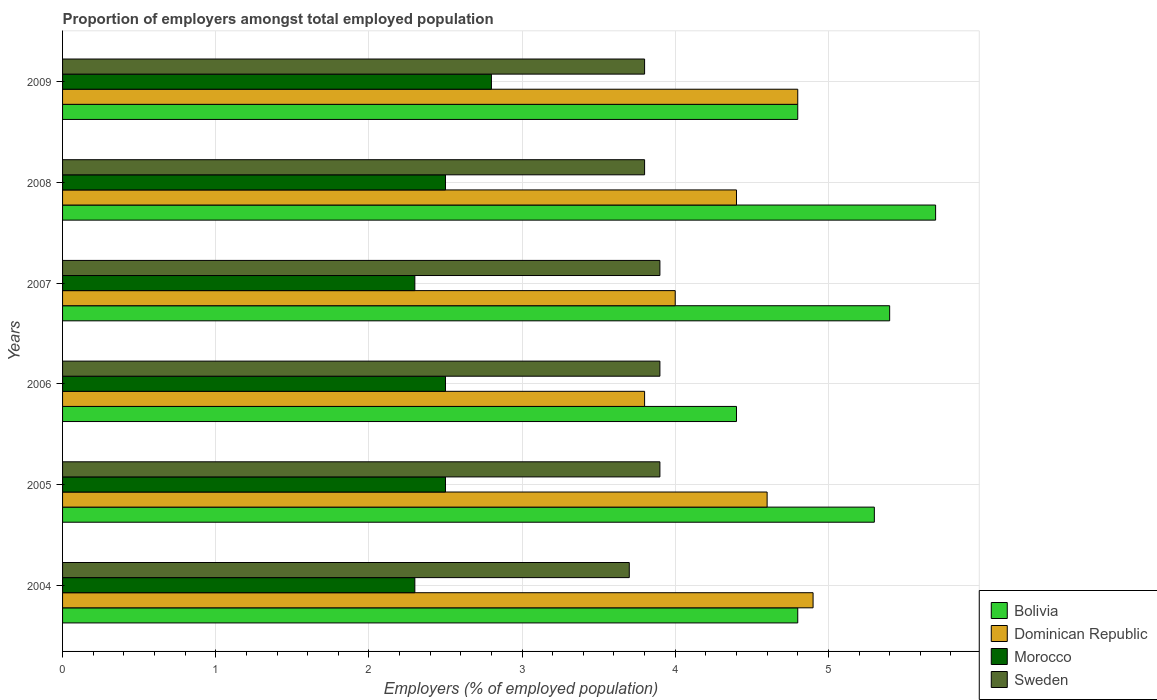How many bars are there on the 1st tick from the top?
Give a very brief answer. 4. How many bars are there on the 5th tick from the bottom?
Keep it short and to the point. 4. In how many cases, is the number of bars for a given year not equal to the number of legend labels?
Make the answer very short. 0. What is the proportion of employers in Dominican Republic in 2005?
Give a very brief answer. 4.6. Across all years, what is the maximum proportion of employers in Sweden?
Give a very brief answer. 3.9. Across all years, what is the minimum proportion of employers in Bolivia?
Your answer should be compact. 4.4. In which year was the proportion of employers in Morocco maximum?
Your answer should be compact. 2009. In which year was the proportion of employers in Bolivia minimum?
Ensure brevity in your answer.  2006. What is the total proportion of employers in Morocco in the graph?
Give a very brief answer. 14.9. What is the difference between the proportion of employers in Sweden in 2005 and that in 2008?
Provide a succinct answer. 0.1. What is the difference between the proportion of employers in Morocco in 2005 and the proportion of employers in Sweden in 2008?
Keep it short and to the point. -1.3. What is the average proportion of employers in Morocco per year?
Your response must be concise. 2.48. In the year 2008, what is the difference between the proportion of employers in Sweden and proportion of employers in Dominican Republic?
Provide a short and direct response. -0.6. In how many years, is the proportion of employers in Dominican Republic greater than 5.4 %?
Keep it short and to the point. 0. What is the ratio of the proportion of employers in Bolivia in 2006 to that in 2009?
Your answer should be compact. 0.92. Is the proportion of employers in Bolivia in 2007 less than that in 2009?
Offer a terse response. No. What is the difference between the highest and the lowest proportion of employers in Bolivia?
Your answer should be compact. 1.3. What does the 3rd bar from the top in 2009 represents?
Offer a very short reply. Dominican Republic. What does the 2nd bar from the bottom in 2004 represents?
Offer a very short reply. Dominican Republic. Is it the case that in every year, the sum of the proportion of employers in Morocco and proportion of employers in Sweden is greater than the proportion of employers in Bolivia?
Your answer should be very brief. Yes. Are all the bars in the graph horizontal?
Give a very brief answer. Yes. How many years are there in the graph?
Provide a succinct answer. 6. Are the values on the major ticks of X-axis written in scientific E-notation?
Provide a short and direct response. No. Does the graph contain any zero values?
Offer a terse response. No. Where does the legend appear in the graph?
Your answer should be very brief. Bottom right. How many legend labels are there?
Make the answer very short. 4. What is the title of the graph?
Keep it short and to the point. Proportion of employers amongst total employed population. What is the label or title of the X-axis?
Offer a terse response. Employers (% of employed population). What is the label or title of the Y-axis?
Your answer should be very brief. Years. What is the Employers (% of employed population) in Bolivia in 2004?
Provide a short and direct response. 4.8. What is the Employers (% of employed population) of Dominican Republic in 2004?
Provide a succinct answer. 4.9. What is the Employers (% of employed population) in Morocco in 2004?
Make the answer very short. 2.3. What is the Employers (% of employed population) in Sweden in 2004?
Make the answer very short. 3.7. What is the Employers (% of employed population) in Bolivia in 2005?
Your answer should be very brief. 5.3. What is the Employers (% of employed population) of Dominican Republic in 2005?
Your response must be concise. 4.6. What is the Employers (% of employed population) of Morocco in 2005?
Offer a very short reply. 2.5. What is the Employers (% of employed population) of Sweden in 2005?
Your answer should be compact. 3.9. What is the Employers (% of employed population) in Bolivia in 2006?
Provide a short and direct response. 4.4. What is the Employers (% of employed population) in Dominican Republic in 2006?
Your response must be concise. 3.8. What is the Employers (% of employed population) of Morocco in 2006?
Ensure brevity in your answer.  2.5. What is the Employers (% of employed population) of Sweden in 2006?
Offer a very short reply. 3.9. What is the Employers (% of employed population) in Bolivia in 2007?
Your answer should be compact. 5.4. What is the Employers (% of employed population) in Dominican Republic in 2007?
Ensure brevity in your answer.  4. What is the Employers (% of employed population) of Morocco in 2007?
Ensure brevity in your answer.  2.3. What is the Employers (% of employed population) in Sweden in 2007?
Make the answer very short. 3.9. What is the Employers (% of employed population) of Bolivia in 2008?
Provide a succinct answer. 5.7. What is the Employers (% of employed population) in Dominican Republic in 2008?
Your response must be concise. 4.4. What is the Employers (% of employed population) of Sweden in 2008?
Your response must be concise. 3.8. What is the Employers (% of employed population) in Bolivia in 2009?
Provide a succinct answer. 4.8. What is the Employers (% of employed population) in Dominican Republic in 2009?
Make the answer very short. 4.8. What is the Employers (% of employed population) of Morocco in 2009?
Make the answer very short. 2.8. What is the Employers (% of employed population) in Sweden in 2009?
Provide a succinct answer. 3.8. Across all years, what is the maximum Employers (% of employed population) in Bolivia?
Make the answer very short. 5.7. Across all years, what is the maximum Employers (% of employed population) in Dominican Republic?
Provide a short and direct response. 4.9. Across all years, what is the maximum Employers (% of employed population) in Morocco?
Make the answer very short. 2.8. Across all years, what is the maximum Employers (% of employed population) of Sweden?
Keep it short and to the point. 3.9. Across all years, what is the minimum Employers (% of employed population) in Bolivia?
Provide a short and direct response. 4.4. Across all years, what is the minimum Employers (% of employed population) of Dominican Republic?
Ensure brevity in your answer.  3.8. Across all years, what is the minimum Employers (% of employed population) of Morocco?
Your answer should be very brief. 2.3. Across all years, what is the minimum Employers (% of employed population) in Sweden?
Keep it short and to the point. 3.7. What is the total Employers (% of employed population) in Bolivia in the graph?
Keep it short and to the point. 30.4. What is the total Employers (% of employed population) of Dominican Republic in the graph?
Give a very brief answer. 26.5. What is the difference between the Employers (% of employed population) of Bolivia in 2004 and that in 2005?
Give a very brief answer. -0.5. What is the difference between the Employers (% of employed population) of Dominican Republic in 2004 and that in 2006?
Give a very brief answer. 1.1. What is the difference between the Employers (% of employed population) in Morocco in 2004 and that in 2007?
Provide a short and direct response. 0. What is the difference between the Employers (% of employed population) in Sweden in 2004 and that in 2007?
Provide a short and direct response. -0.2. What is the difference between the Employers (% of employed population) of Bolivia in 2004 and that in 2008?
Keep it short and to the point. -0.9. What is the difference between the Employers (% of employed population) of Morocco in 2004 and that in 2008?
Provide a succinct answer. -0.2. What is the difference between the Employers (% of employed population) of Sweden in 2004 and that in 2008?
Offer a very short reply. -0.1. What is the difference between the Employers (% of employed population) in Bolivia in 2004 and that in 2009?
Give a very brief answer. 0. What is the difference between the Employers (% of employed population) of Morocco in 2004 and that in 2009?
Make the answer very short. -0.5. What is the difference between the Employers (% of employed population) in Sweden in 2004 and that in 2009?
Ensure brevity in your answer.  -0.1. What is the difference between the Employers (% of employed population) in Morocco in 2005 and that in 2006?
Make the answer very short. 0. What is the difference between the Employers (% of employed population) of Sweden in 2005 and that in 2006?
Your response must be concise. 0. What is the difference between the Employers (% of employed population) of Bolivia in 2005 and that in 2007?
Offer a terse response. -0.1. What is the difference between the Employers (% of employed population) in Dominican Republic in 2005 and that in 2007?
Make the answer very short. 0.6. What is the difference between the Employers (% of employed population) of Morocco in 2005 and that in 2007?
Ensure brevity in your answer.  0.2. What is the difference between the Employers (% of employed population) of Bolivia in 2005 and that in 2008?
Ensure brevity in your answer.  -0.4. What is the difference between the Employers (% of employed population) of Sweden in 2005 and that in 2008?
Ensure brevity in your answer.  0.1. What is the difference between the Employers (% of employed population) of Bolivia in 2005 and that in 2009?
Give a very brief answer. 0.5. What is the difference between the Employers (% of employed population) of Sweden in 2005 and that in 2009?
Make the answer very short. 0.1. What is the difference between the Employers (% of employed population) in Morocco in 2006 and that in 2007?
Your answer should be very brief. 0.2. What is the difference between the Employers (% of employed population) of Dominican Republic in 2006 and that in 2008?
Offer a terse response. -0.6. What is the difference between the Employers (% of employed population) of Morocco in 2006 and that in 2008?
Offer a very short reply. 0. What is the difference between the Employers (% of employed population) in Sweden in 2006 and that in 2008?
Keep it short and to the point. 0.1. What is the difference between the Employers (% of employed population) of Dominican Republic in 2006 and that in 2009?
Ensure brevity in your answer.  -1. What is the difference between the Employers (% of employed population) in Morocco in 2006 and that in 2009?
Your answer should be compact. -0.3. What is the difference between the Employers (% of employed population) of Sweden in 2006 and that in 2009?
Ensure brevity in your answer.  0.1. What is the difference between the Employers (% of employed population) of Bolivia in 2007 and that in 2008?
Keep it short and to the point. -0.3. What is the difference between the Employers (% of employed population) in Dominican Republic in 2007 and that in 2008?
Offer a very short reply. -0.4. What is the difference between the Employers (% of employed population) of Bolivia in 2008 and that in 2009?
Make the answer very short. 0.9. What is the difference between the Employers (% of employed population) of Morocco in 2008 and that in 2009?
Your answer should be very brief. -0.3. What is the difference between the Employers (% of employed population) in Sweden in 2008 and that in 2009?
Offer a terse response. 0. What is the difference between the Employers (% of employed population) of Bolivia in 2004 and the Employers (% of employed population) of Dominican Republic in 2005?
Offer a very short reply. 0.2. What is the difference between the Employers (% of employed population) of Bolivia in 2004 and the Employers (% of employed population) of Sweden in 2005?
Keep it short and to the point. 0.9. What is the difference between the Employers (% of employed population) in Dominican Republic in 2004 and the Employers (% of employed population) in Sweden in 2005?
Keep it short and to the point. 1. What is the difference between the Employers (% of employed population) in Morocco in 2004 and the Employers (% of employed population) in Sweden in 2005?
Provide a succinct answer. -1.6. What is the difference between the Employers (% of employed population) in Bolivia in 2004 and the Employers (% of employed population) in Dominican Republic in 2006?
Your answer should be very brief. 1. What is the difference between the Employers (% of employed population) in Bolivia in 2004 and the Employers (% of employed population) in Morocco in 2006?
Provide a short and direct response. 2.3. What is the difference between the Employers (% of employed population) of Dominican Republic in 2004 and the Employers (% of employed population) of Morocco in 2006?
Offer a terse response. 2.4. What is the difference between the Employers (% of employed population) in Morocco in 2004 and the Employers (% of employed population) in Sweden in 2006?
Keep it short and to the point. -1.6. What is the difference between the Employers (% of employed population) of Dominican Republic in 2004 and the Employers (% of employed population) of Morocco in 2007?
Ensure brevity in your answer.  2.6. What is the difference between the Employers (% of employed population) in Morocco in 2004 and the Employers (% of employed population) in Sweden in 2007?
Give a very brief answer. -1.6. What is the difference between the Employers (% of employed population) of Dominican Republic in 2004 and the Employers (% of employed population) of Morocco in 2008?
Offer a very short reply. 2.4. What is the difference between the Employers (% of employed population) in Dominican Republic in 2004 and the Employers (% of employed population) in Sweden in 2008?
Your answer should be compact. 1.1. What is the difference between the Employers (% of employed population) of Bolivia in 2004 and the Employers (% of employed population) of Morocco in 2009?
Offer a terse response. 2. What is the difference between the Employers (% of employed population) of Bolivia in 2004 and the Employers (% of employed population) of Sweden in 2009?
Provide a short and direct response. 1. What is the difference between the Employers (% of employed population) of Dominican Republic in 2004 and the Employers (% of employed population) of Sweden in 2009?
Your response must be concise. 1.1. What is the difference between the Employers (% of employed population) in Morocco in 2004 and the Employers (% of employed population) in Sweden in 2009?
Provide a short and direct response. -1.5. What is the difference between the Employers (% of employed population) in Dominican Republic in 2005 and the Employers (% of employed population) in Sweden in 2006?
Your answer should be very brief. 0.7. What is the difference between the Employers (% of employed population) of Morocco in 2005 and the Employers (% of employed population) of Sweden in 2006?
Give a very brief answer. -1.4. What is the difference between the Employers (% of employed population) in Dominican Republic in 2005 and the Employers (% of employed population) in Sweden in 2007?
Keep it short and to the point. 0.7. What is the difference between the Employers (% of employed population) in Bolivia in 2005 and the Employers (% of employed population) in Dominican Republic in 2008?
Ensure brevity in your answer.  0.9. What is the difference between the Employers (% of employed population) of Bolivia in 2005 and the Employers (% of employed population) of Sweden in 2008?
Ensure brevity in your answer.  1.5. What is the difference between the Employers (% of employed population) in Dominican Republic in 2005 and the Employers (% of employed population) in Morocco in 2008?
Your answer should be compact. 2.1. What is the difference between the Employers (% of employed population) of Dominican Republic in 2005 and the Employers (% of employed population) of Sweden in 2008?
Offer a very short reply. 0.8. What is the difference between the Employers (% of employed population) of Morocco in 2005 and the Employers (% of employed population) of Sweden in 2008?
Give a very brief answer. -1.3. What is the difference between the Employers (% of employed population) in Bolivia in 2005 and the Employers (% of employed population) in Sweden in 2009?
Offer a terse response. 1.5. What is the difference between the Employers (% of employed population) in Dominican Republic in 2005 and the Employers (% of employed population) in Morocco in 2009?
Provide a succinct answer. 1.8. What is the difference between the Employers (% of employed population) of Dominican Republic in 2005 and the Employers (% of employed population) of Sweden in 2009?
Offer a very short reply. 0.8. What is the difference between the Employers (% of employed population) of Bolivia in 2006 and the Employers (% of employed population) of Dominican Republic in 2007?
Provide a succinct answer. 0.4. What is the difference between the Employers (% of employed population) in Bolivia in 2006 and the Employers (% of employed population) in Morocco in 2007?
Your answer should be compact. 2.1. What is the difference between the Employers (% of employed population) in Dominican Republic in 2006 and the Employers (% of employed population) in Sweden in 2007?
Offer a very short reply. -0.1. What is the difference between the Employers (% of employed population) in Bolivia in 2006 and the Employers (% of employed population) in Dominican Republic in 2008?
Offer a very short reply. 0. What is the difference between the Employers (% of employed population) in Bolivia in 2006 and the Employers (% of employed population) in Sweden in 2008?
Provide a short and direct response. 0.6. What is the difference between the Employers (% of employed population) in Dominican Republic in 2006 and the Employers (% of employed population) in Morocco in 2008?
Give a very brief answer. 1.3. What is the difference between the Employers (% of employed population) in Dominican Republic in 2006 and the Employers (% of employed population) in Sweden in 2008?
Your answer should be very brief. 0. What is the difference between the Employers (% of employed population) of Bolivia in 2006 and the Employers (% of employed population) of Dominican Republic in 2009?
Offer a terse response. -0.4. What is the difference between the Employers (% of employed population) in Bolivia in 2006 and the Employers (% of employed population) in Sweden in 2009?
Your response must be concise. 0.6. What is the difference between the Employers (% of employed population) of Dominican Republic in 2006 and the Employers (% of employed population) of Sweden in 2009?
Make the answer very short. 0. What is the difference between the Employers (% of employed population) in Morocco in 2006 and the Employers (% of employed population) in Sweden in 2009?
Give a very brief answer. -1.3. What is the difference between the Employers (% of employed population) in Bolivia in 2007 and the Employers (% of employed population) in Dominican Republic in 2008?
Make the answer very short. 1. What is the difference between the Employers (% of employed population) of Bolivia in 2007 and the Employers (% of employed population) of Morocco in 2008?
Keep it short and to the point. 2.9. What is the difference between the Employers (% of employed population) of Bolivia in 2007 and the Employers (% of employed population) of Sweden in 2008?
Your answer should be very brief. 1.6. What is the difference between the Employers (% of employed population) in Bolivia in 2007 and the Employers (% of employed population) in Dominican Republic in 2009?
Make the answer very short. 0.6. What is the difference between the Employers (% of employed population) of Dominican Republic in 2007 and the Employers (% of employed population) of Morocco in 2009?
Your answer should be very brief. 1.2. What is the difference between the Employers (% of employed population) of Bolivia in 2008 and the Employers (% of employed population) of Dominican Republic in 2009?
Your response must be concise. 0.9. What is the difference between the Employers (% of employed population) of Bolivia in 2008 and the Employers (% of employed population) of Sweden in 2009?
Ensure brevity in your answer.  1.9. What is the difference between the Employers (% of employed population) of Morocco in 2008 and the Employers (% of employed population) of Sweden in 2009?
Keep it short and to the point. -1.3. What is the average Employers (% of employed population) of Bolivia per year?
Your answer should be very brief. 5.07. What is the average Employers (% of employed population) of Dominican Republic per year?
Offer a very short reply. 4.42. What is the average Employers (% of employed population) in Morocco per year?
Provide a short and direct response. 2.48. What is the average Employers (% of employed population) in Sweden per year?
Your response must be concise. 3.83. In the year 2004, what is the difference between the Employers (% of employed population) in Morocco and Employers (% of employed population) in Sweden?
Give a very brief answer. -1.4. In the year 2005, what is the difference between the Employers (% of employed population) in Dominican Republic and Employers (% of employed population) in Morocco?
Provide a short and direct response. 2.1. In the year 2006, what is the difference between the Employers (% of employed population) in Bolivia and Employers (% of employed population) in Dominican Republic?
Ensure brevity in your answer.  0.6. In the year 2006, what is the difference between the Employers (% of employed population) of Bolivia and Employers (% of employed population) of Morocco?
Provide a succinct answer. 1.9. In the year 2006, what is the difference between the Employers (% of employed population) in Bolivia and Employers (% of employed population) in Sweden?
Give a very brief answer. 0.5. In the year 2006, what is the difference between the Employers (% of employed population) in Dominican Republic and Employers (% of employed population) in Morocco?
Keep it short and to the point. 1.3. In the year 2006, what is the difference between the Employers (% of employed population) in Morocco and Employers (% of employed population) in Sweden?
Provide a succinct answer. -1.4. In the year 2007, what is the difference between the Employers (% of employed population) of Bolivia and Employers (% of employed population) of Dominican Republic?
Provide a succinct answer. 1.4. In the year 2007, what is the difference between the Employers (% of employed population) of Dominican Republic and Employers (% of employed population) of Morocco?
Make the answer very short. 1.7. In the year 2007, what is the difference between the Employers (% of employed population) of Dominican Republic and Employers (% of employed population) of Sweden?
Give a very brief answer. 0.1. In the year 2008, what is the difference between the Employers (% of employed population) in Bolivia and Employers (% of employed population) in Morocco?
Keep it short and to the point. 3.2. In the year 2008, what is the difference between the Employers (% of employed population) of Bolivia and Employers (% of employed population) of Sweden?
Make the answer very short. 1.9. In the year 2008, what is the difference between the Employers (% of employed population) in Dominican Republic and Employers (% of employed population) in Morocco?
Offer a very short reply. 1.9. In the year 2008, what is the difference between the Employers (% of employed population) in Dominican Republic and Employers (% of employed population) in Sweden?
Keep it short and to the point. 0.6. In the year 2009, what is the difference between the Employers (% of employed population) in Bolivia and Employers (% of employed population) in Dominican Republic?
Your response must be concise. 0. In the year 2009, what is the difference between the Employers (% of employed population) of Bolivia and Employers (% of employed population) of Sweden?
Provide a succinct answer. 1. In the year 2009, what is the difference between the Employers (% of employed population) of Dominican Republic and Employers (% of employed population) of Morocco?
Your answer should be compact. 2. In the year 2009, what is the difference between the Employers (% of employed population) in Dominican Republic and Employers (% of employed population) in Sweden?
Ensure brevity in your answer.  1. What is the ratio of the Employers (% of employed population) in Bolivia in 2004 to that in 2005?
Offer a terse response. 0.91. What is the ratio of the Employers (% of employed population) in Dominican Republic in 2004 to that in 2005?
Your answer should be very brief. 1.07. What is the ratio of the Employers (% of employed population) in Morocco in 2004 to that in 2005?
Give a very brief answer. 0.92. What is the ratio of the Employers (% of employed population) in Sweden in 2004 to that in 2005?
Your response must be concise. 0.95. What is the ratio of the Employers (% of employed population) of Dominican Republic in 2004 to that in 2006?
Provide a short and direct response. 1.29. What is the ratio of the Employers (% of employed population) in Sweden in 2004 to that in 2006?
Your response must be concise. 0.95. What is the ratio of the Employers (% of employed population) in Bolivia in 2004 to that in 2007?
Provide a succinct answer. 0.89. What is the ratio of the Employers (% of employed population) of Dominican Republic in 2004 to that in 2007?
Your answer should be very brief. 1.23. What is the ratio of the Employers (% of employed population) in Sweden in 2004 to that in 2007?
Provide a short and direct response. 0.95. What is the ratio of the Employers (% of employed population) in Bolivia in 2004 to that in 2008?
Offer a very short reply. 0.84. What is the ratio of the Employers (% of employed population) in Dominican Republic in 2004 to that in 2008?
Offer a very short reply. 1.11. What is the ratio of the Employers (% of employed population) in Morocco in 2004 to that in 2008?
Make the answer very short. 0.92. What is the ratio of the Employers (% of employed population) in Sweden in 2004 to that in 2008?
Keep it short and to the point. 0.97. What is the ratio of the Employers (% of employed population) of Bolivia in 2004 to that in 2009?
Keep it short and to the point. 1. What is the ratio of the Employers (% of employed population) in Dominican Republic in 2004 to that in 2009?
Offer a very short reply. 1.02. What is the ratio of the Employers (% of employed population) in Morocco in 2004 to that in 2009?
Your answer should be very brief. 0.82. What is the ratio of the Employers (% of employed population) in Sweden in 2004 to that in 2009?
Give a very brief answer. 0.97. What is the ratio of the Employers (% of employed population) of Bolivia in 2005 to that in 2006?
Provide a short and direct response. 1.2. What is the ratio of the Employers (% of employed population) in Dominican Republic in 2005 to that in 2006?
Ensure brevity in your answer.  1.21. What is the ratio of the Employers (% of employed population) of Morocco in 2005 to that in 2006?
Provide a short and direct response. 1. What is the ratio of the Employers (% of employed population) in Sweden in 2005 to that in 2006?
Ensure brevity in your answer.  1. What is the ratio of the Employers (% of employed population) in Bolivia in 2005 to that in 2007?
Provide a short and direct response. 0.98. What is the ratio of the Employers (% of employed population) in Dominican Republic in 2005 to that in 2007?
Offer a terse response. 1.15. What is the ratio of the Employers (% of employed population) of Morocco in 2005 to that in 2007?
Offer a very short reply. 1.09. What is the ratio of the Employers (% of employed population) in Bolivia in 2005 to that in 2008?
Your answer should be compact. 0.93. What is the ratio of the Employers (% of employed population) of Dominican Republic in 2005 to that in 2008?
Your answer should be very brief. 1.05. What is the ratio of the Employers (% of employed population) in Sweden in 2005 to that in 2008?
Provide a succinct answer. 1.03. What is the ratio of the Employers (% of employed population) in Bolivia in 2005 to that in 2009?
Provide a short and direct response. 1.1. What is the ratio of the Employers (% of employed population) in Dominican Republic in 2005 to that in 2009?
Your answer should be very brief. 0.96. What is the ratio of the Employers (% of employed population) in Morocco in 2005 to that in 2009?
Give a very brief answer. 0.89. What is the ratio of the Employers (% of employed population) of Sweden in 2005 to that in 2009?
Your answer should be compact. 1.03. What is the ratio of the Employers (% of employed population) of Bolivia in 2006 to that in 2007?
Offer a terse response. 0.81. What is the ratio of the Employers (% of employed population) of Dominican Republic in 2006 to that in 2007?
Give a very brief answer. 0.95. What is the ratio of the Employers (% of employed population) in Morocco in 2006 to that in 2007?
Make the answer very short. 1.09. What is the ratio of the Employers (% of employed population) in Sweden in 2006 to that in 2007?
Give a very brief answer. 1. What is the ratio of the Employers (% of employed population) in Bolivia in 2006 to that in 2008?
Your answer should be very brief. 0.77. What is the ratio of the Employers (% of employed population) of Dominican Republic in 2006 to that in 2008?
Ensure brevity in your answer.  0.86. What is the ratio of the Employers (% of employed population) of Morocco in 2006 to that in 2008?
Offer a terse response. 1. What is the ratio of the Employers (% of employed population) in Sweden in 2006 to that in 2008?
Your response must be concise. 1.03. What is the ratio of the Employers (% of employed population) in Bolivia in 2006 to that in 2009?
Keep it short and to the point. 0.92. What is the ratio of the Employers (% of employed population) in Dominican Republic in 2006 to that in 2009?
Provide a short and direct response. 0.79. What is the ratio of the Employers (% of employed population) of Morocco in 2006 to that in 2009?
Offer a terse response. 0.89. What is the ratio of the Employers (% of employed population) of Sweden in 2006 to that in 2009?
Ensure brevity in your answer.  1.03. What is the ratio of the Employers (% of employed population) of Dominican Republic in 2007 to that in 2008?
Make the answer very short. 0.91. What is the ratio of the Employers (% of employed population) of Morocco in 2007 to that in 2008?
Offer a terse response. 0.92. What is the ratio of the Employers (% of employed population) of Sweden in 2007 to that in 2008?
Provide a succinct answer. 1.03. What is the ratio of the Employers (% of employed population) of Dominican Republic in 2007 to that in 2009?
Your response must be concise. 0.83. What is the ratio of the Employers (% of employed population) of Morocco in 2007 to that in 2009?
Your answer should be compact. 0.82. What is the ratio of the Employers (% of employed population) in Sweden in 2007 to that in 2009?
Give a very brief answer. 1.03. What is the ratio of the Employers (% of employed population) in Bolivia in 2008 to that in 2009?
Give a very brief answer. 1.19. What is the ratio of the Employers (% of employed population) in Dominican Republic in 2008 to that in 2009?
Give a very brief answer. 0.92. What is the ratio of the Employers (% of employed population) in Morocco in 2008 to that in 2009?
Your answer should be very brief. 0.89. What is the difference between the highest and the second highest Employers (% of employed population) in Dominican Republic?
Your answer should be compact. 0.1. What is the difference between the highest and the second highest Employers (% of employed population) of Sweden?
Offer a terse response. 0. 